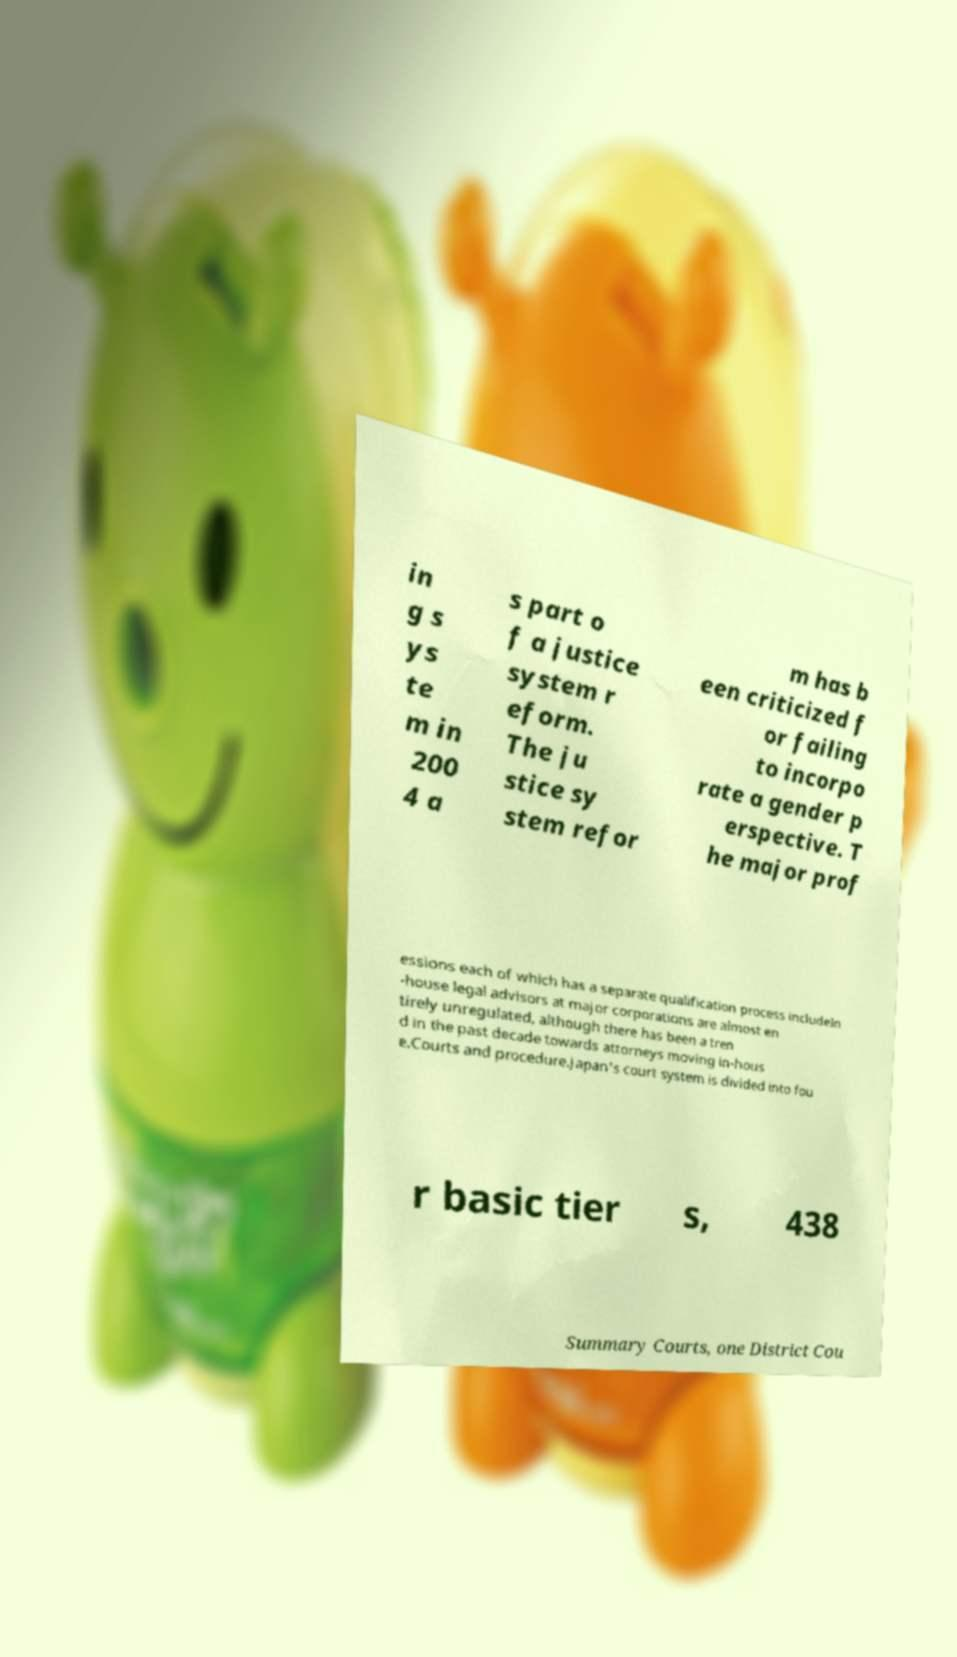There's text embedded in this image that I need extracted. Can you transcribe it verbatim? in g s ys te m in 200 4 a s part o f a justice system r eform. The ju stice sy stem refor m has b een criticized f or failing to incorpo rate a gender p erspective. T he major prof essions each of which has a separate qualification process includeIn -house legal advisors at major corporations are almost en tirely unregulated, although there has been a tren d in the past decade towards attorneys moving in-hous e.Courts and procedure.Japan's court system is divided into fou r basic tier s, 438 Summary Courts, one District Cou 